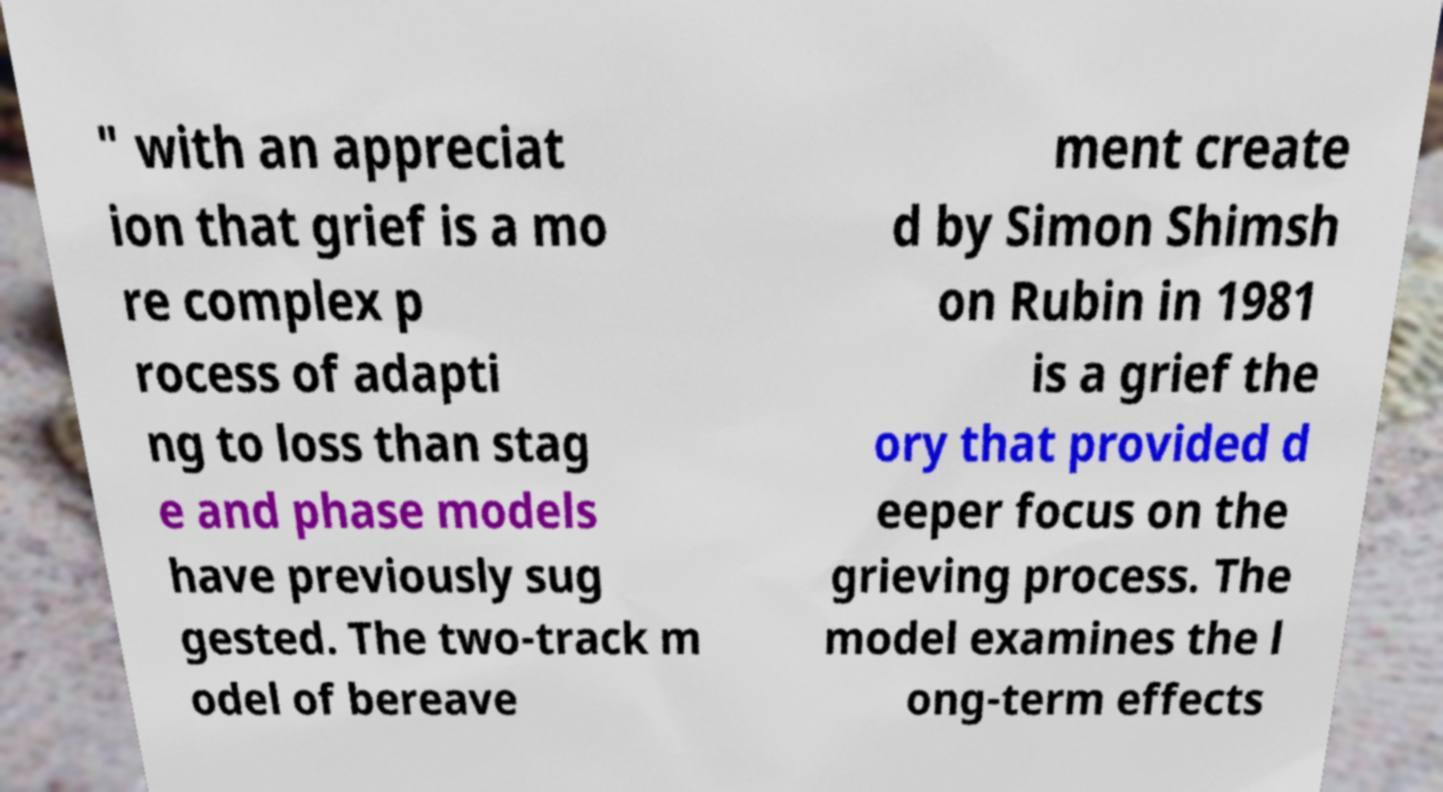Please identify and transcribe the text found in this image. " with an appreciat ion that grief is a mo re complex p rocess of adapti ng to loss than stag e and phase models have previously sug gested. The two-track m odel of bereave ment create d by Simon Shimsh on Rubin in 1981 is a grief the ory that provided d eeper focus on the grieving process. The model examines the l ong-term effects 